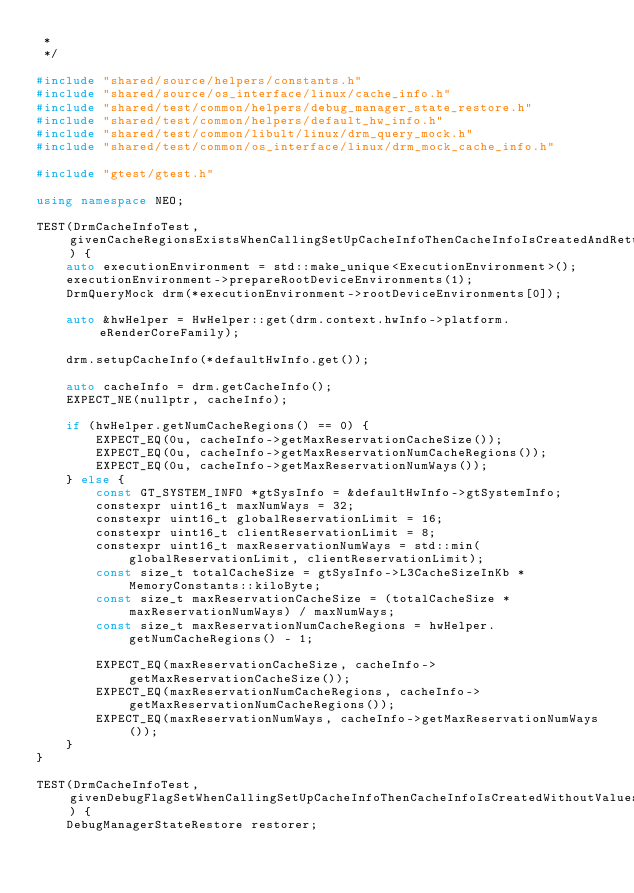Convert code to text. <code><loc_0><loc_0><loc_500><loc_500><_C++_> *
 */

#include "shared/source/helpers/constants.h"
#include "shared/source/os_interface/linux/cache_info.h"
#include "shared/test/common/helpers/debug_manager_state_restore.h"
#include "shared/test/common/helpers/default_hw_info.h"
#include "shared/test/common/libult/linux/drm_query_mock.h"
#include "shared/test/common/os_interface/linux/drm_mock_cache_info.h"

#include "gtest/gtest.h"

using namespace NEO;

TEST(DrmCacheInfoTest, givenCacheRegionsExistsWhenCallingSetUpCacheInfoThenCacheInfoIsCreatedAndReturnsMaxReservationCacheLimits) {
    auto executionEnvironment = std::make_unique<ExecutionEnvironment>();
    executionEnvironment->prepareRootDeviceEnvironments(1);
    DrmQueryMock drm(*executionEnvironment->rootDeviceEnvironments[0]);

    auto &hwHelper = HwHelper::get(drm.context.hwInfo->platform.eRenderCoreFamily);

    drm.setupCacheInfo(*defaultHwInfo.get());

    auto cacheInfo = drm.getCacheInfo();
    EXPECT_NE(nullptr, cacheInfo);

    if (hwHelper.getNumCacheRegions() == 0) {
        EXPECT_EQ(0u, cacheInfo->getMaxReservationCacheSize());
        EXPECT_EQ(0u, cacheInfo->getMaxReservationNumCacheRegions());
        EXPECT_EQ(0u, cacheInfo->getMaxReservationNumWays());
    } else {
        const GT_SYSTEM_INFO *gtSysInfo = &defaultHwInfo->gtSystemInfo;
        constexpr uint16_t maxNumWays = 32;
        constexpr uint16_t globalReservationLimit = 16;
        constexpr uint16_t clientReservationLimit = 8;
        constexpr uint16_t maxReservationNumWays = std::min(globalReservationLimit, clientReservationLimit);
        const size_t totalCacheSize = gtSysInfo->L3CacheSizeInKb * MemoryConstants::kiloByte;
        const size_t maxReservationCacheSize = (totalCacheSize * maxReservationNumWays) / maxNumWays;
        const size_t maxReservationNumCacheRegions = hwHelper.getNumCacheRegions() - 1;

        EXPECT_EQ(maxReservationCacheSize, cacheInfo->getMaxReservationCacheSize());
        EXPECT_EQ(maxReservationNumCacheRegions, cacheInfo->getMaxReservationNumCacheRegions());
        EXPECT_EQ(maxReservationNumWays, cacheInfo->getMaxReservationNumWays());
    }
}

TEST(DrmCacheInfoTest, givenDebugFlagSetWhenCallingSetUpCacheInfoThenCacheInfoIsCreatedWithoutValues) {
    DebugManagerStateRestore restorer;</code> 